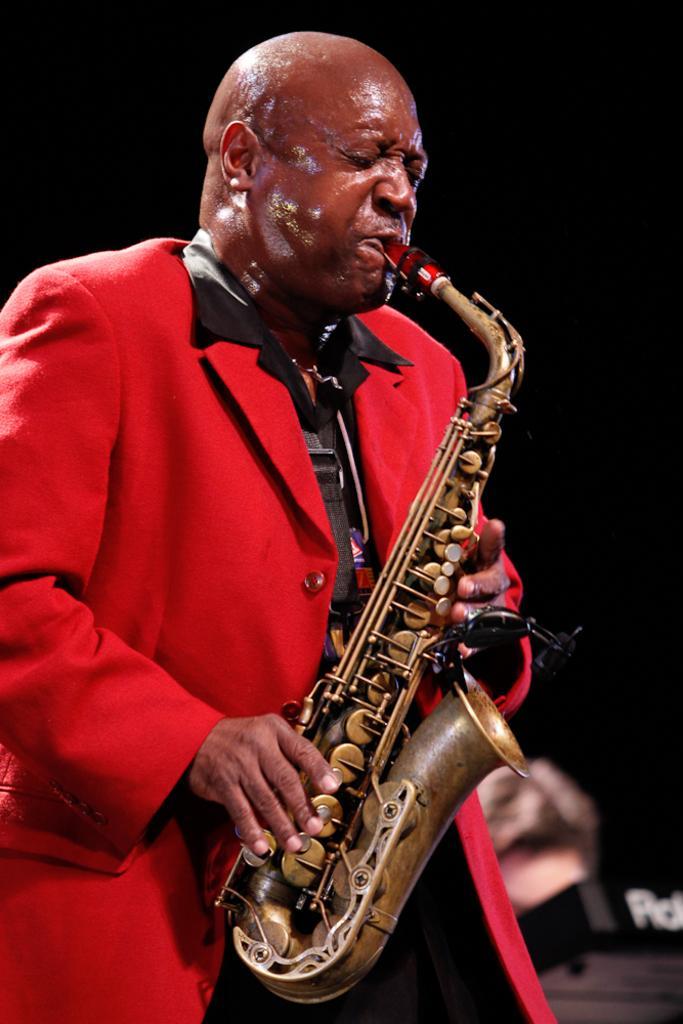In one or two sentences, can you explain what this image depicts? In this image there is a person playing trombone. 